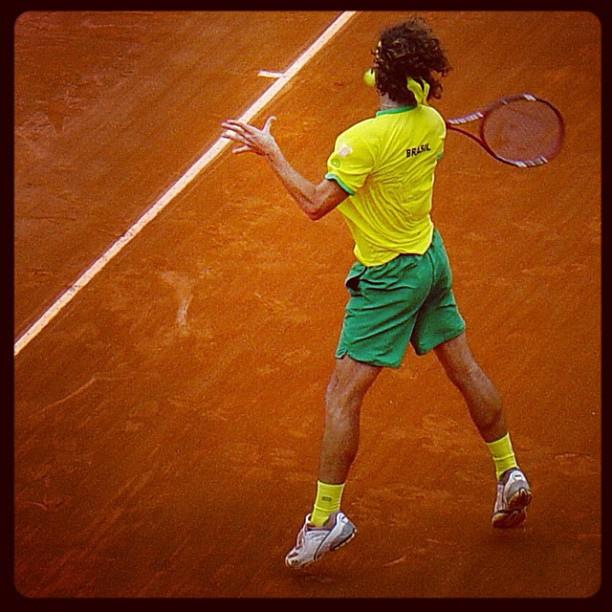What color socks are they?
Answer briefly. Yellow. What sport are they playing?
Quick response, please. Tennis. What other color besides green and white on the ground?
Write a very short answer. Brown. Is the player all dressed in white?
Short answer required. No. What sport is being played?
Quick response, please. Tennis. What color are the socks?
Keep it brief. Yellow. 